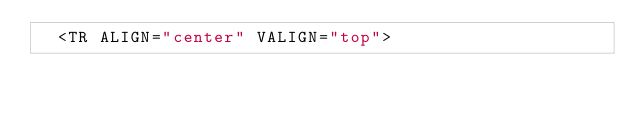<code> <loc_0><loc_0><loc_500><loc_500><_HTML_>  <TR ALIGN="center" VALIGN="top"></code> 